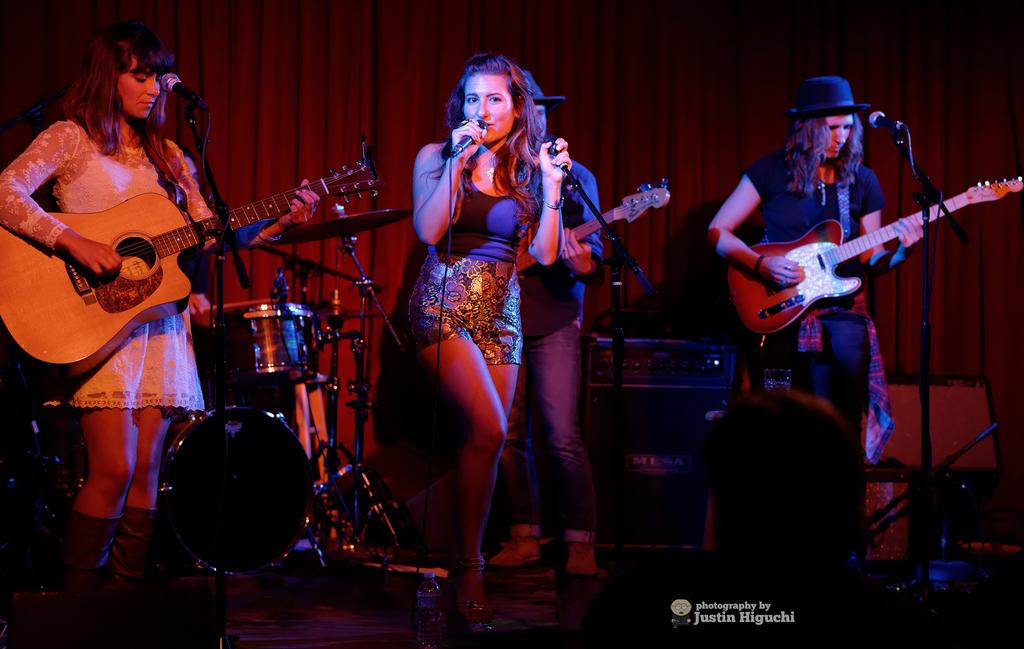What is the woman in the center of the image doing? The woman in the center of the image is standing and singing. What can be seen on the left side of the image? There are other women on the left side of the image. What activity is one of the women on the left side of the image engaged in? At least one of the women on the left is playing the guitar. What type of fowl is present in the image? There is no fowl present in the image; it features women singing and playing the guitar. How many feet are visible in the image? The number of feet visible in the image cannot be determined from the provided facts, as the focus is on the women and their activities. 